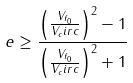<formula> <loc_0><loc_0><loc_500><loc_500>e \geq \frac { \left ( \frac { V _ { f _ { 0 } } } { V _ { c } i r c } \right ) ^ { 2 } - 1 } { \left ( \frac { V _ { f _ { 0 } } } { V _ { c } i r c } \right ) ^ { 2 } + 1 }</formula> 